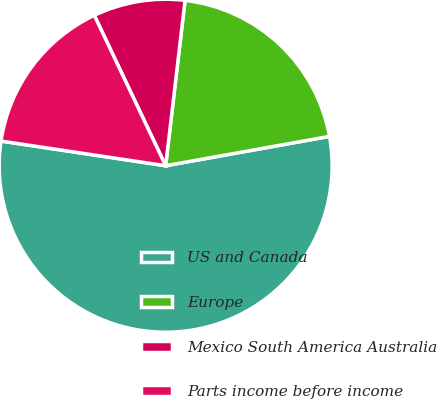Convert chart to OTSL. <chart><loc_0><loc_0><loc_500><loc_500><pie_chart><fcel>US and Canada<fcel>Europe<fcel>Mexico South America Australia<fcel>Parts income before income<nl><fcel>55.19%<fcel>20.32%<fcel>8.91%<fcel>15.58%<nl></chart> 